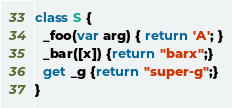Convert code to text. <code><loc_0><loc_0><loc_500><loc_500><_Dart_>
class S {
  _foo(var arg) { return 'A'; }
  _bar([x]) {return "barx";}
  get _g {return "super-g";}
}
</code> 